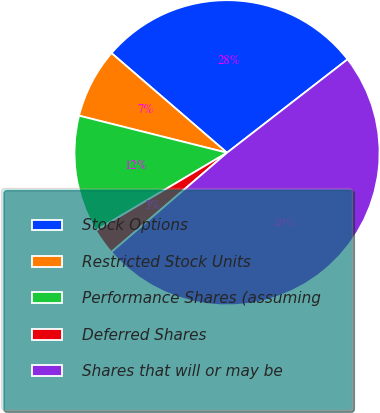Convert chart to OTSL. <chart><loc_0><loc_0><loc_500><loc_500><pie_chart><fcel>Stock Options<fcel>Restricted Stock Units<fcel>Performance Shares (assuming<fcel>Deferred Shares<fcel>Shares that will or may be<nl><fcel>28.18%<fcel>7.42%<fcel>12.43%<fcel>2.77%<fcel>49.2%<nl></chart> 